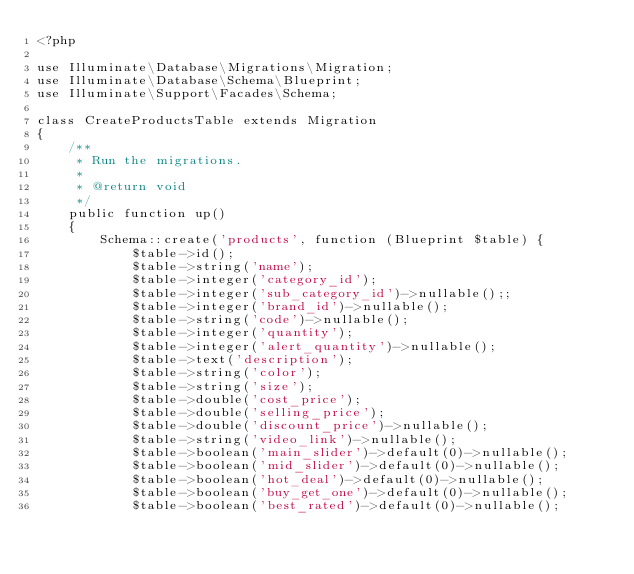<code> <loc_0><loc_0><loc_500><loc_500><_PHP_><?php

use Illuminate\Database\Migrations\Migration;
use Illuminate\Database\Schema\Blueprint;
use Illuminate\Support\Facades\Schema;

class CreateProductsTable extends Migration
{
    /**
     * Run the migrations.
     *
     * @return void
     */
    public function up()
    {
        Schema::create('products', function (Blueprint $table) {
            $table->id();
            $table->string('name');
            $table->integer('category_id');
            $table->integer('sub_category_id')->nullable();;
            $table->integer('brand_id')->nullable();
            $table->string('code')->nullable();
            $table->integer('quantity');
            $table->integer('alert_quantity')->nullable();
            $table->text('description');
            $table->string('color');
            $table->string('size');
            $table->double('cost_price');
            $table->double('selling_price');
            $table->double('discount_price')->nullable();
            $table->string('video_link')->nullable();
            $table->boolean('main_slider')->default(0)->nullable();
            $table->boolean('mid_slider')->default(0)->nullable();
            $table->boolean('hot_deal')->default(0)->nullable();
            $table->boolean('buy_get_one')->default(0)->nullable();
            $table->boolean('best_rated')->default(0)->nullable();</code> 